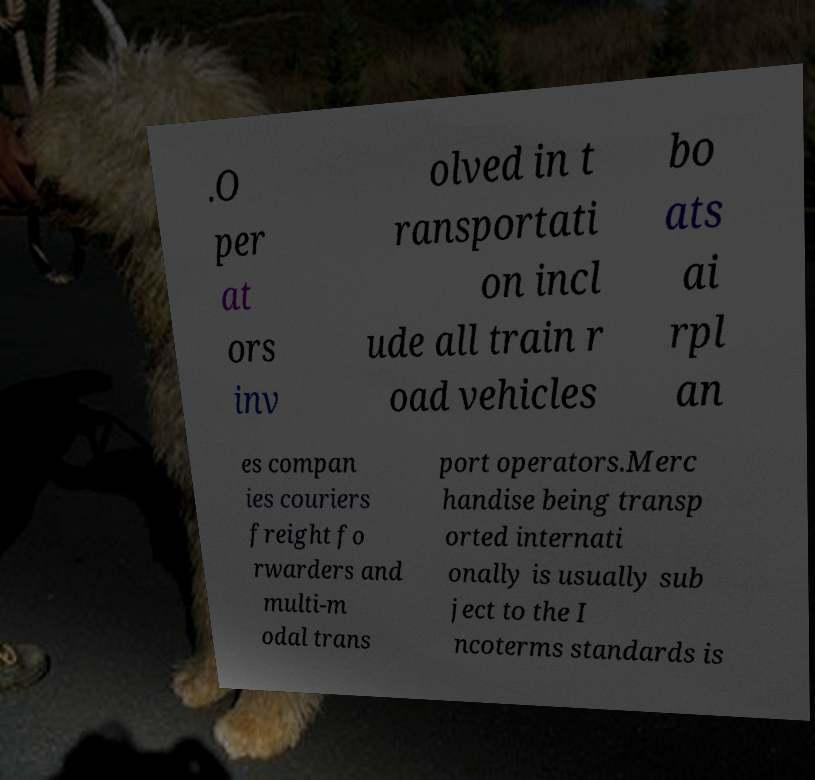What messages or text are displayed in this image? I need them in a readable, typed format. .O per at ors inv olved in t ransportati on incl ude all train r oad vehicles bo ats ai rpl an es compan ies couriers freight fo rwarders and multi-m odal trans port operators.Merc handise being transp orted internati onally is usually sub ject to the I ncoterms standards is 